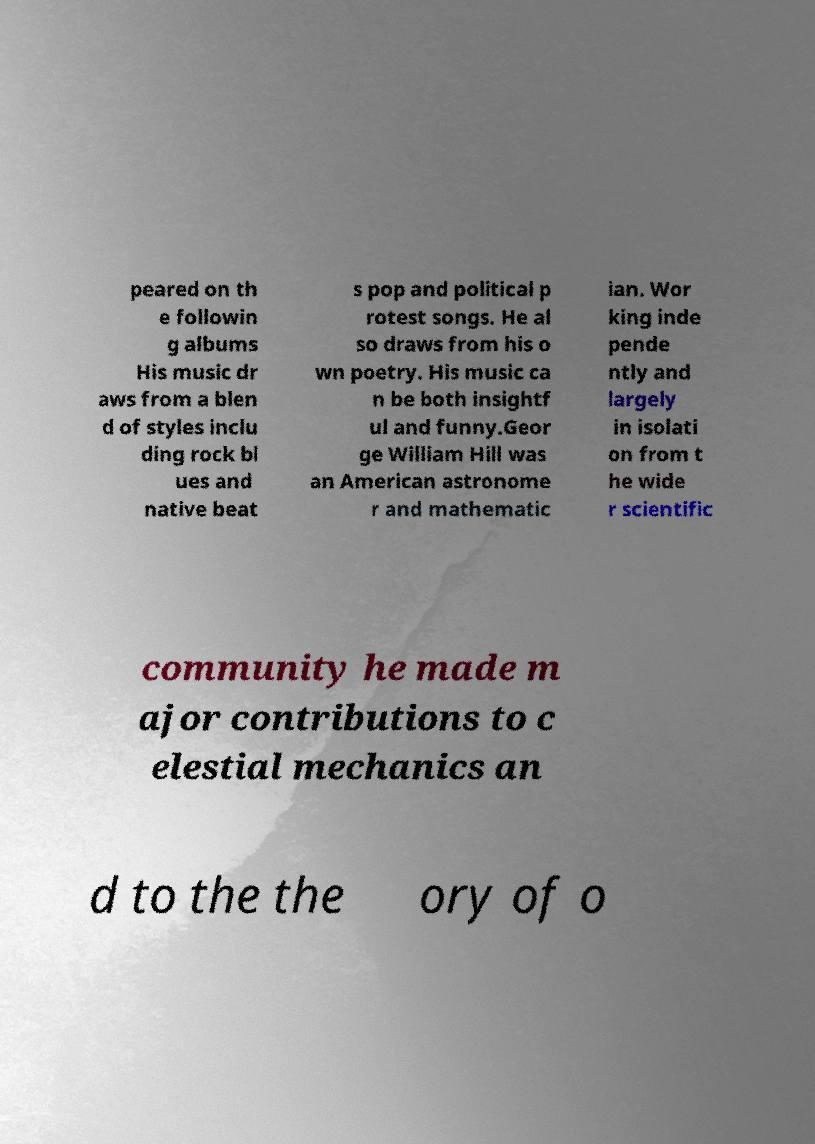Could you assist in decoding the text presented in this image and type it out clearly? peared on th e followin g albums His music dr aws from a blen d of styles inclu ding rock bl ues and native beat s pop and political p rotest songs. He al so draws from his o wn poetry. His music ca n be both insightf ul and funny.Geor ge William Hill was an American astronome r and mathematic ian. Wor king inde pende ntly and largely in isolati on from t he wide r scientific community he made m ajor contributions to c elestial mechanics an d to the the ory of o 